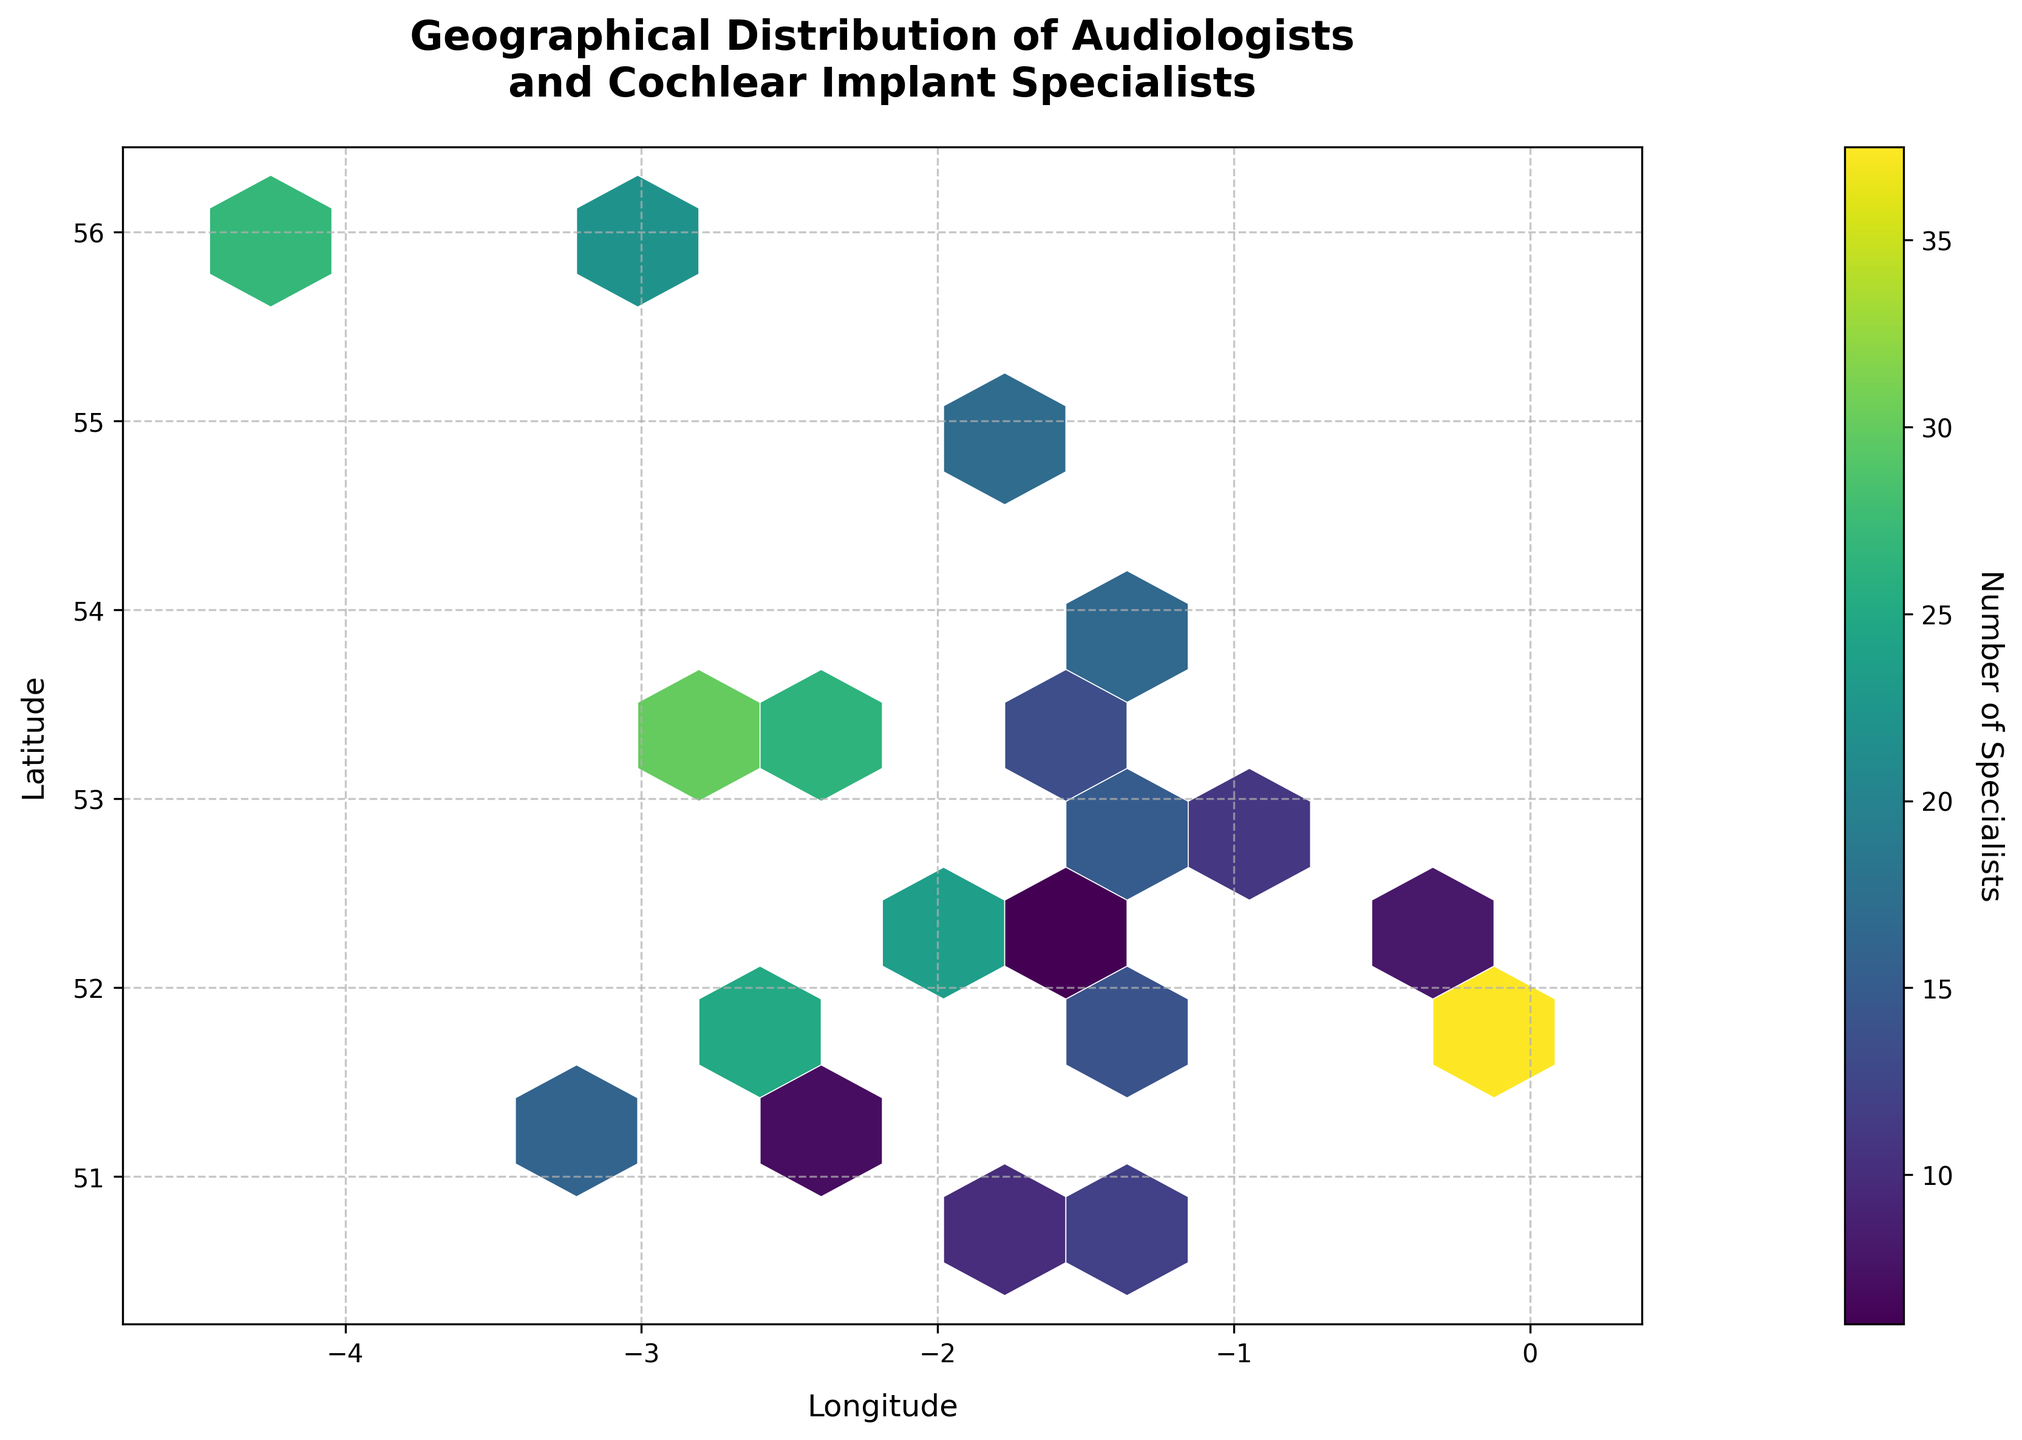What is the title of the hexbin plot? The title of the plot is usually found at the top of the figure, giving an overview of what the plot represents. Here, the title is "Geographical Distribution of Audiologists and Cochlear Implant Specialists".
Answer: Geographical Distribution of Audiologists and Cochlear Implant Specialists What do the x and y axes represent on the hexbin plot? The x and y axes typically have labels that describe the data they represent. For this plot, the x-axis is labeled "Longitude" and the y-axis is labeled "Latitude".
Answer: Longitude and Latitude What does the color gradient in the hexbin plot signify? In a hexbin plot, the color gradient represents the intensity or quantity of data points within each hexagon. Here, it indicates the number of specialists. The color bar legend to the right of the plot helps in understanding this.
Answer: Number of Specialists Which area seems to have the highest concentration of specialists? To determine the area with the highest concentration of specialists, look for the hexagon with the darkest color, as indicated by the color gradient. This is around the coordinates (51.5074, -0.1278), which corresponds to London.
Answer: London What is the approximate number of specialists in the densest hexagon? By referring to the darkest hexagon and looking at the color bar legend, you can match the color to its corresponding value. The approximate number of specialists is around 42 in the densest hexagon.
Answer: About 42 Which city in the northern region has a noticeable concentration of specialists? Identify cities in the northern region by their latitude and check for significant hexbin activity. The darker hexagons located at around (55.9533, -3.1883) indicate Edinburgh has a noticeable concentration of specialists.
Answer: Edinburgh Which two locations have similar concentrations of specialists? Compare hexagons of similar color intensity. Cities like Leeds (53.7996, -1.5491) and Bristol (51.4545, -2.5879) show similar colors, indicating similar numbers of specialists at around 20-25.
Answer: Leeds and Bristol Comparing cities, does Manchester (53.4808, -2.2426) or Glasgow (55.8642, -4.2518) have more specialists? Comparing the colors of the hexagons representing Manchester and Glasgow, Manchester has darker hexagons indicating a higher number of specialists, around 35 compared to Glasgow's 27.
Answer: Manchester What is the average number of specialists in the cities Birmingham (52.4862, -1.8904) and Liverpool (53.4084, -2.9916)? To find the average, sum the number of specialists in Birmingham (28 + 19) and Liverpool (30) and divide by the total locations. The sum is 77; now averaging over 3 numbers: 77/3 = 25.67.
Answer: 25.67 How does the geographic distribution of specialists appear—more concentrated in specific areas or evenly spread out? Observing the plot reveals more concentration in major cities like London, Manchester, and Glasgow, indicated by darker hexagons, while other areas show lighter, more spread out hexagons.
Answer: More concentrated in specific areas 